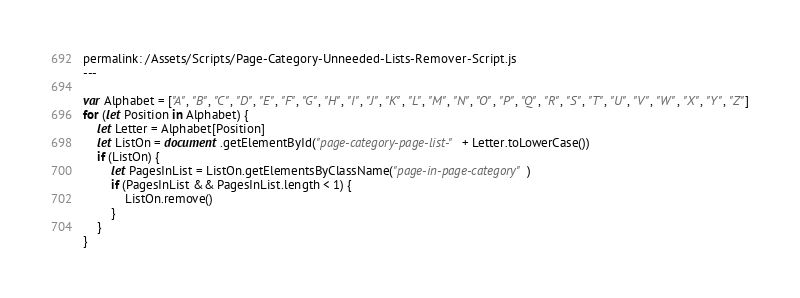Convert code to text. <code><loc_0><loc_0><loc_500><loc_500><_JavaScript_>permalink: /Assets/Scripts/Page-Category-Unneeded-Lists-Remover-Script.js
---

var Alphabet = ["A", "B", "C", "D", "E", "F", "G", "H", "I", "J", "K", "L", "M", "N", "O", "P", "Q", "R", "S", "T", "U", "V", "W", "X", "Y", "Z"]
for (let Position in Alphabet) {
	let Letter = Alphabet[Position]
	let ListOn = document.getElementById("page-category-page-list-" + Letter.toLowerCase())
	if (ListOn) {
		let PagesInList = ListOn.getElementsByClassName("page-in-page-category")
		if (PagesInList && PagesInList.length < 1) {
			ListOn.remove()
		}
	}
}</code> 